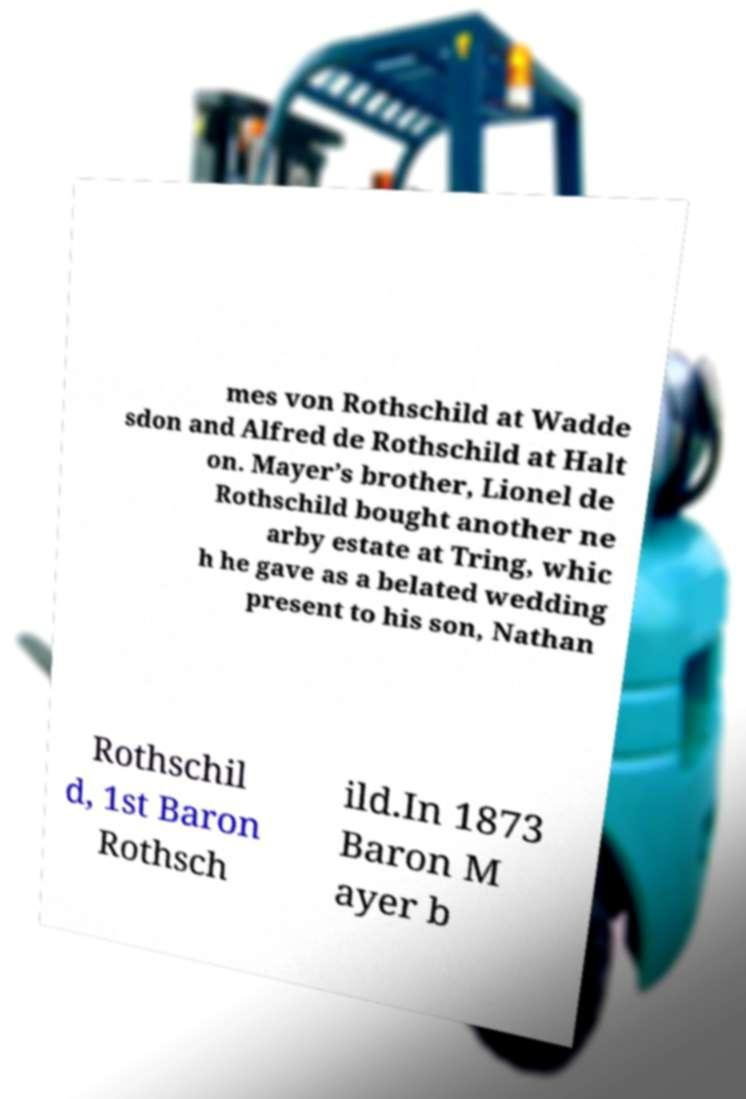Can you read and provide the text displayed in the image?This photo seems to have some interesting text. Can you extract and type it out for me? mes von Rothschild at Wadde sdon and Alfred de Rothschild at Halt on. Mayer’s brother, Lionel de Rothschild bought another ne arby estate at Tring, whic h he gave as a belated wedding present to his son, Nathan Rothschil d, 1st Baron Rothsch ild.In 1873 Baron M ayer b 